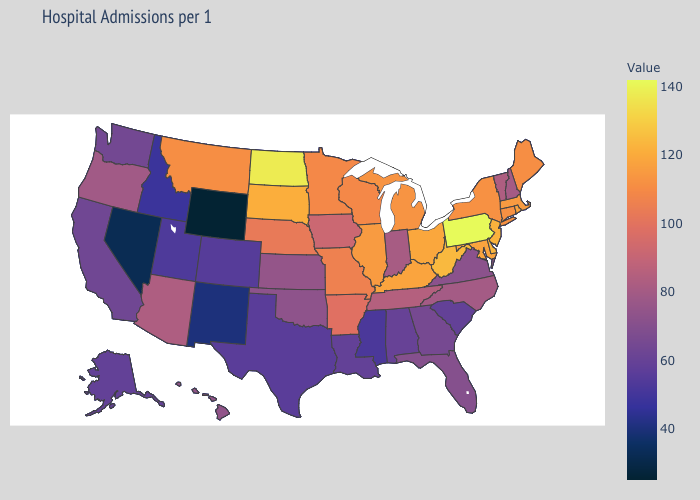Does Colorado have a lower value than New Mexico?
Quick response, please. No. Does Tennessee have a higher value than Florida?
Answer briefly. Yes. Among the states that border Vermont , does New York have the lowest value?
Answer briefly. No. 